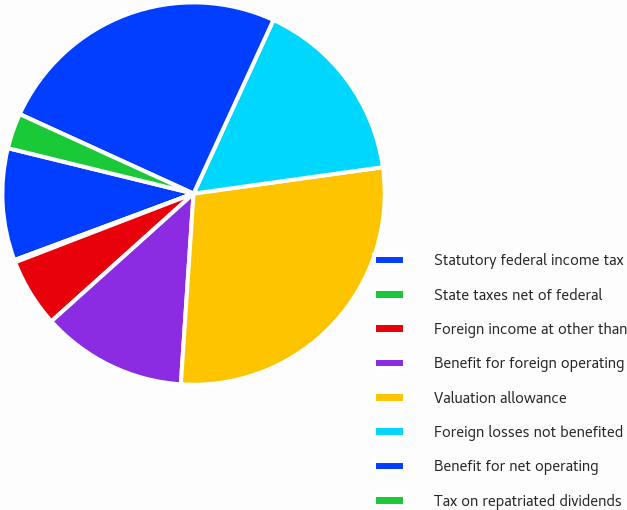Convert chart. <chart><loc_0><loc_0><loc_500><loc_500><pie_chart><fcel>Statutory federal income tax<fcel>State taxes net of federal<fcel>Foreign income at other than<fcel>Benefit for foreign operating<fcel>Valuation allowance<fcel>Foreign losses not benefited<fcel>Benefit for net operating<fcel>Tax on repatriated dividends<nl><fcel>9.48%<fcel>0.19%<fcel>5.8%<fcel>12.29%<fcel>28.26%<fcel>15.93%<fcel>25.04%<fcel>3.0%<nl></chart> 